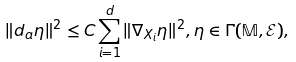Convert formula to latex. <formula><loc_0><loc_0><loc_500><loc_500>\| d _ { a } \eta \| ^ { 2 } \leq C \sum _ { i = 1 } ^ { d } \| \nabla _ { X _ { i } } \eta \| ^ { 2 } , \eta \in \Gamma ( \mathbb { M } , \mathcal { E } ) ,</formula> 